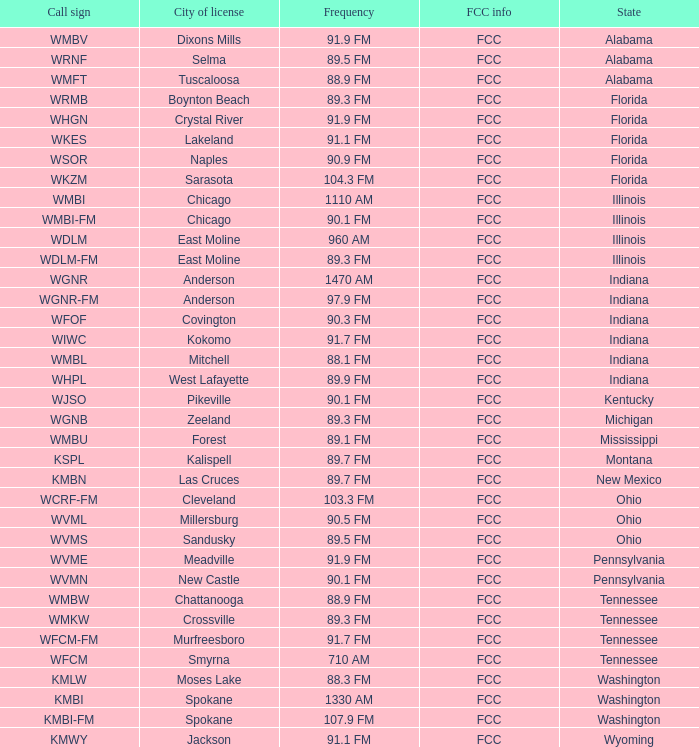What is the FCC info for the radio station in West Lafayette, Indiana? FCC. 